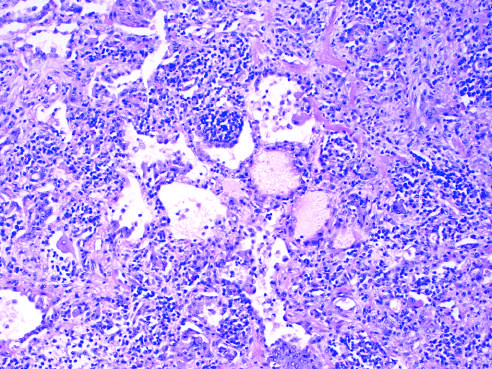s a myofiber distended with trypanosomes infiltrated with lymphocytes and some plasma cells, which are spilling over into alveolar spaces?
Answer the question using a single word or phrase. No 